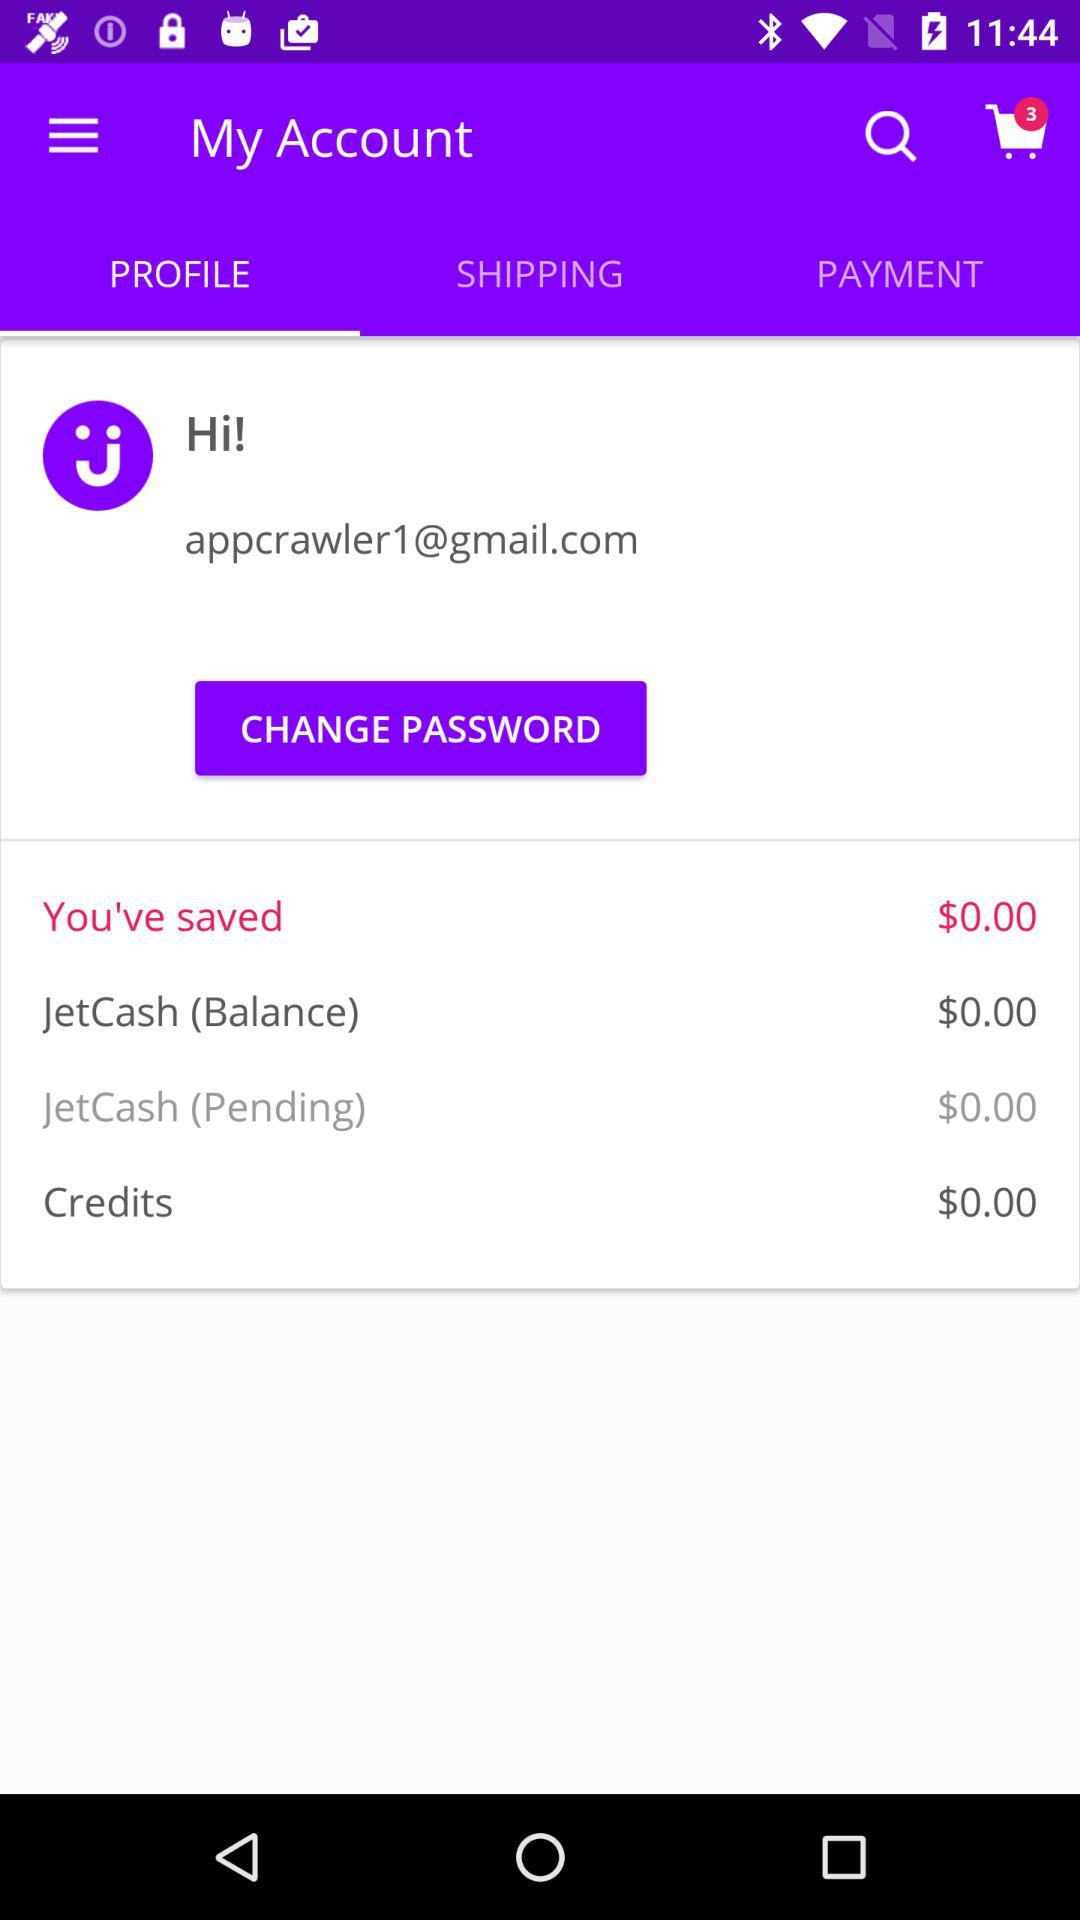What is the email address? The email address is appcrawler1@gmail.com. 